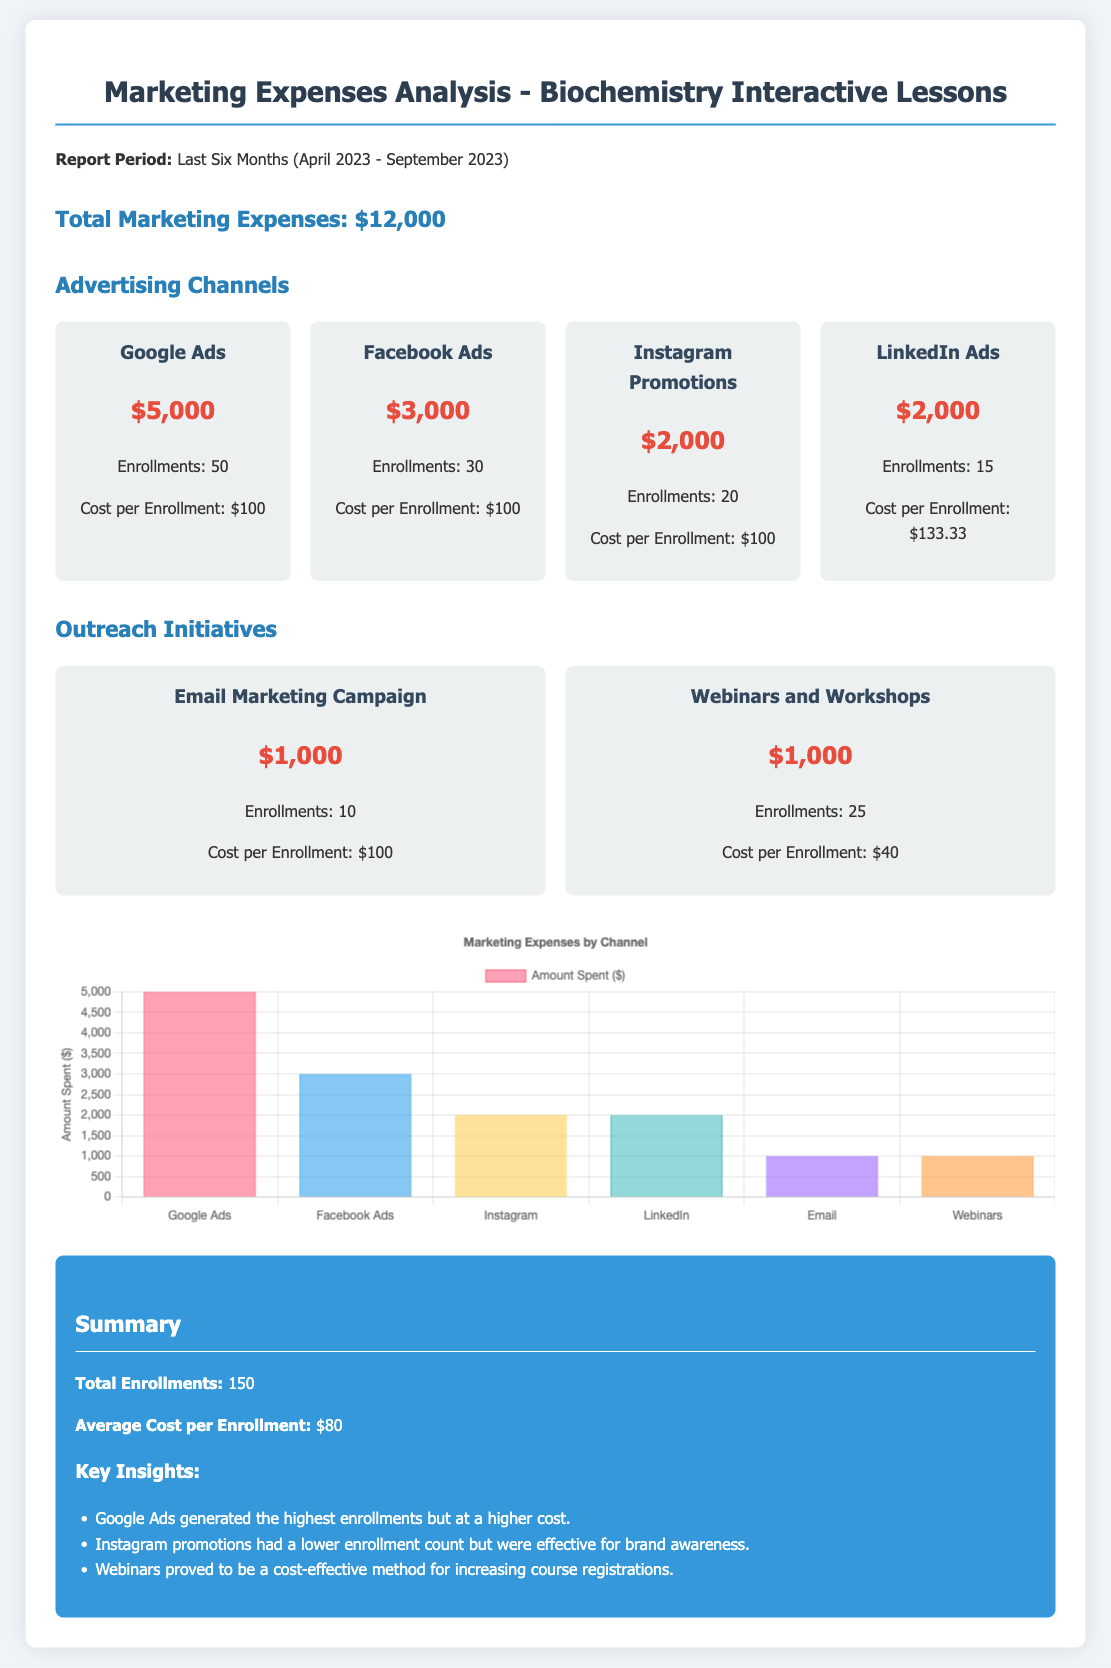What is the total marketing expense? The total marketing expense is stated in the document, and it is $12,000.
Answer: $12,000 How much was spent on Google Ads? The document specifies the amount spent on Google Ads is $5,000.
Answer: $5,000 How many enrollments were generated by Facebook Ads? The specific number of enrollments from Facebook Ads is mentioned in the document as 30.
Answer: 30 What is the cost per enrollment for the Webinars and Workshops? The document provides the cost per enrollment for this initiative as $40.
Answer: $40 Which advertising channel had the highest enrollment? The highest enrollment is attributed to Google Ads, as stated in the document.
Answer: Google Ads What was the total number of enrollments recorded? The total number of enrollments is summarized in the document as 150.
Answer: 150 Which outreach initiative generated the lowest cost per enrollment? The initiative with the lowest cost per enrollment is Webinars and Workshops at $40.
Answer: Webinars and Workshops How much was allocated to Email Marketing Campaign? The document indicates that $1,000 was allocated to Email Marketing Campaign.
Answer: $1,000 What is the average cost per enrollment? The document summarizes the average cost per enrollment as $80.
Answer: $80 